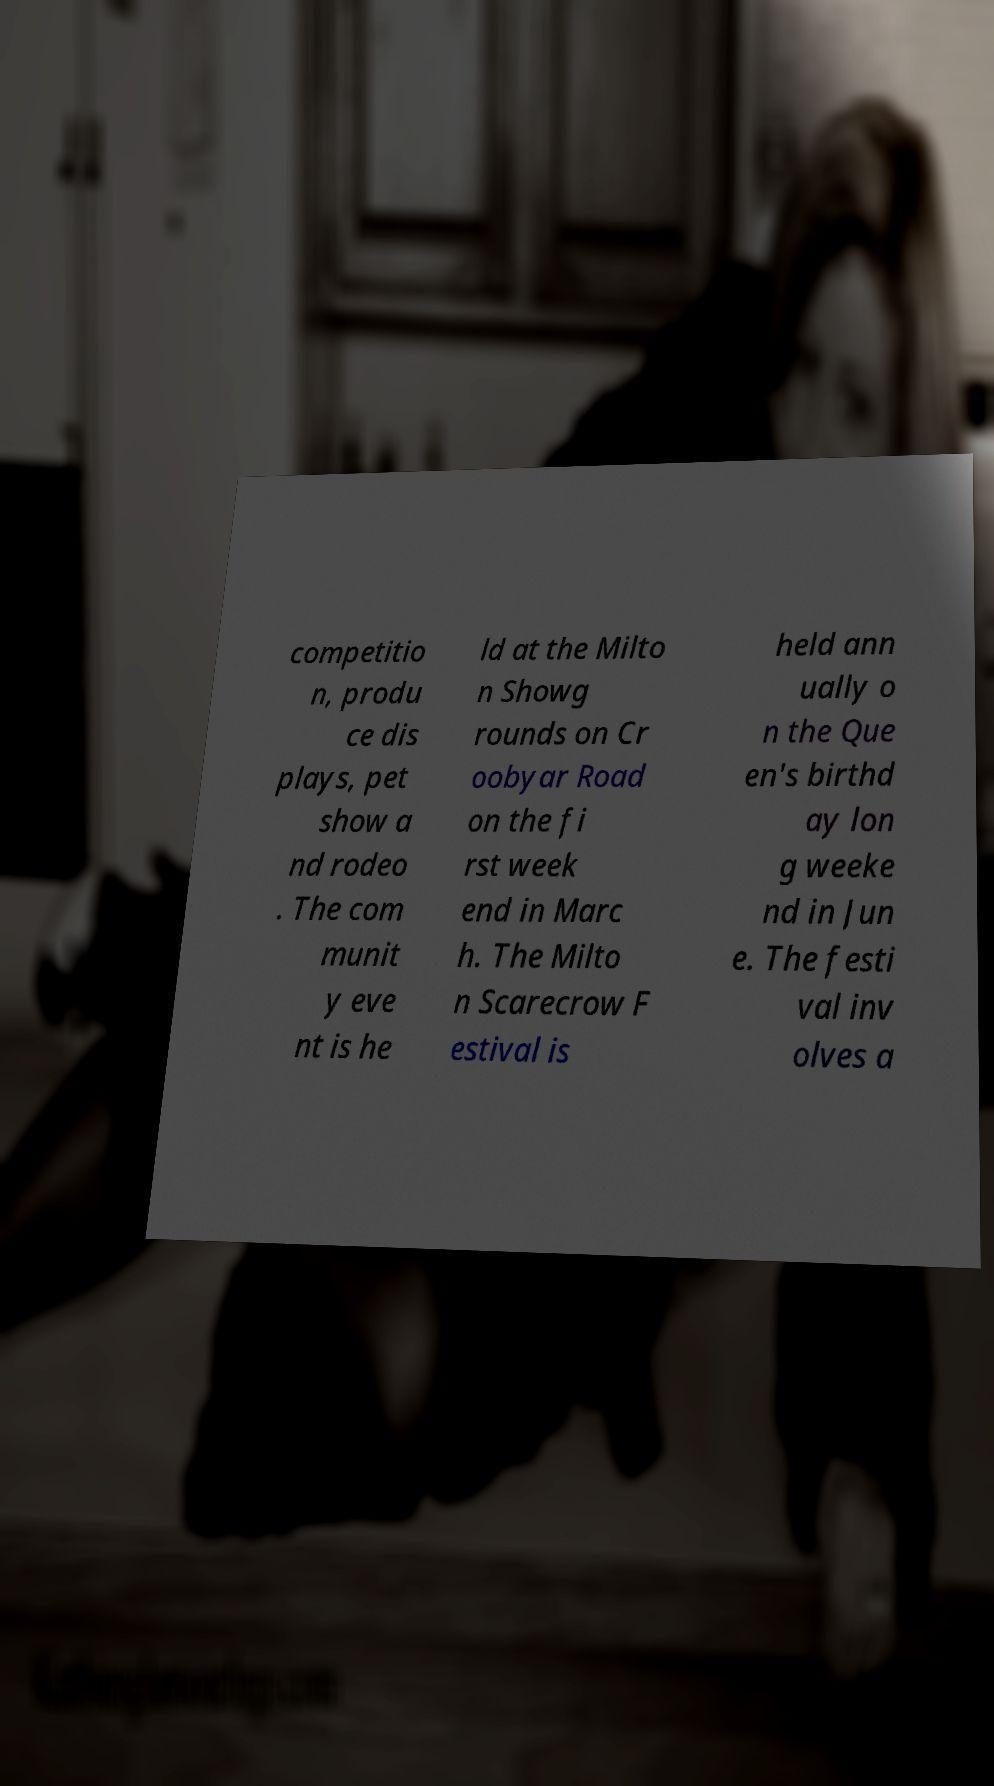For documentation purposes, I need the text within this image transcribed. Could you provide that? competitio n, produ ce dis plays, pet show a nd rodeo . The com munit y eve nt is he ld at the Milto n Showg rounds on Cr oobyar Road on the fi rst week end in Marc h. The Milto n Scarecrow F estival is held ann ually o n the Que en's birthd ay lon g weeke nd in Jun e. The festi val inv olves a 